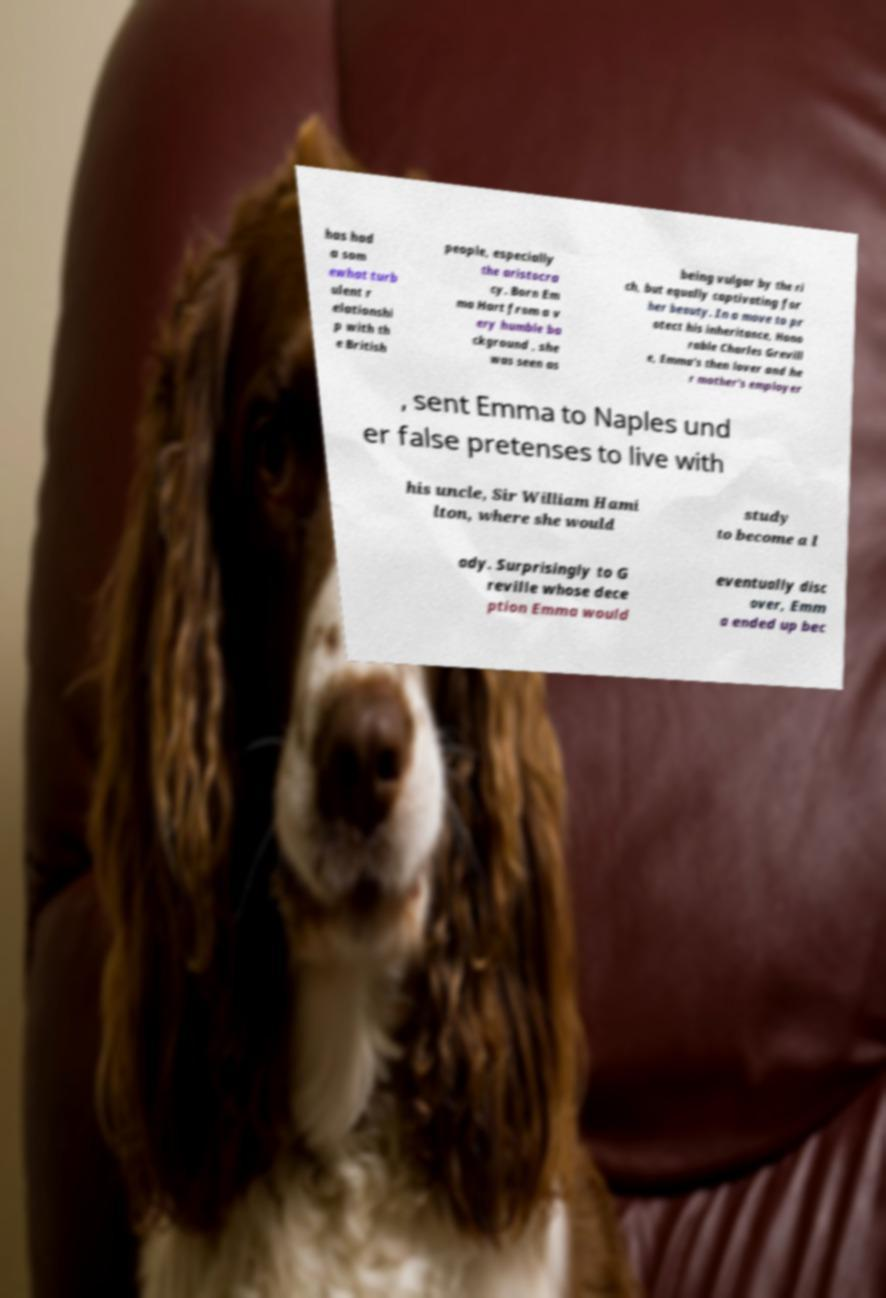Please identify and transcribe the text found in this image. has had a som ewhat turb ulent r elationshi p with th e British people, especially the aristocra cy. Born Em ma Hart from a v ery humble ba ckground , she was seen as being vulgar by the ri ch, but equally captivating for her beauty. In a move to pr otect his inheritance, Hono rable Charles Grevill e, Emma's then lover and he r mother's employer , sent Emma to Naples und er false pretenses to live with his uncle, Sir William Hami lton, where she would study to become a l ady. Surprisingly to G reville whose dece ption Emma would eventually disc over, Emm a ended up bec 